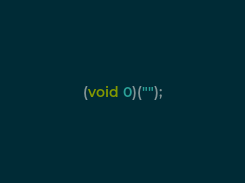<code> <loc_0><loc_0><loc_500><loc_500><_JavaScript_>(void 0)("");
</code> 